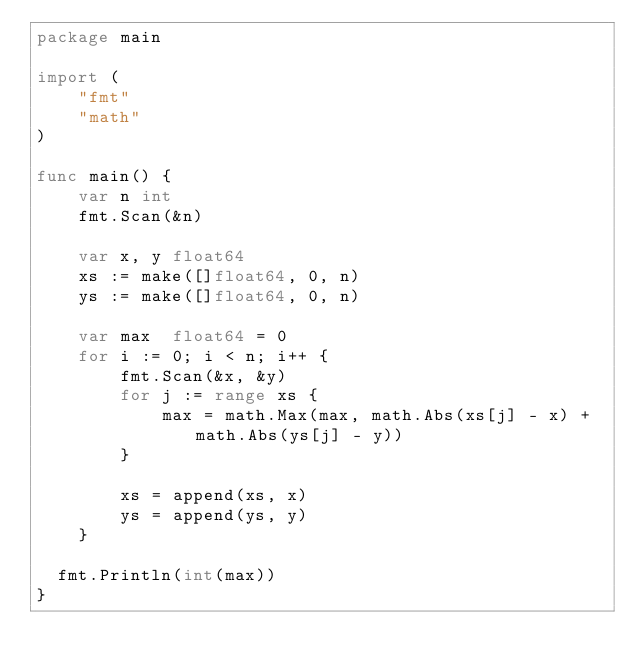<code> <loc_0><loc_0><loc_500><loc_500><_Go_>package main

import (
	"fmt"
	"math"
)

func main() {
	var n int
	fmt.Scan(&n)

	var x, y float64
	xs := make([]float64, 0, n)
	ys := make([]float64, 0, n)

	var max  float64 = 0
	for i := 0; i < n; i++ {
		fmt.Scan(&x, &y)
		for j := range xs {
			max = math.Max(max, math.Abs(xs[j] - x) + math.Abs(ys[j] - y))
		}

		xs = append(xs, x)
		ys = append(ys, y)
	}

  fmt.Println(int(max))
}</code> 